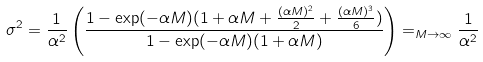Convert formula to latex. <formula><loc_0><loc_0><loc_500><loc_500>\sigma ^ { 2 } = \frac { 1 } { \alpha ^ { 2 } } \left ( \frac { 1 - \exp ( - \alpha M ) ( 1 + \alpha M + \frac { ( \alpha M ) ^ { 2 } } { 2 } + \frac { ( \alpha M ) ^ { 3 } } { 6 } ) } { 1 - \exp ( - \alpha M ) ( 1 + \alpha M ) } \right ) = _ { M \rightarrow \infty } \frac { 1 } { \alpha ^ { 2 } }</formula> 